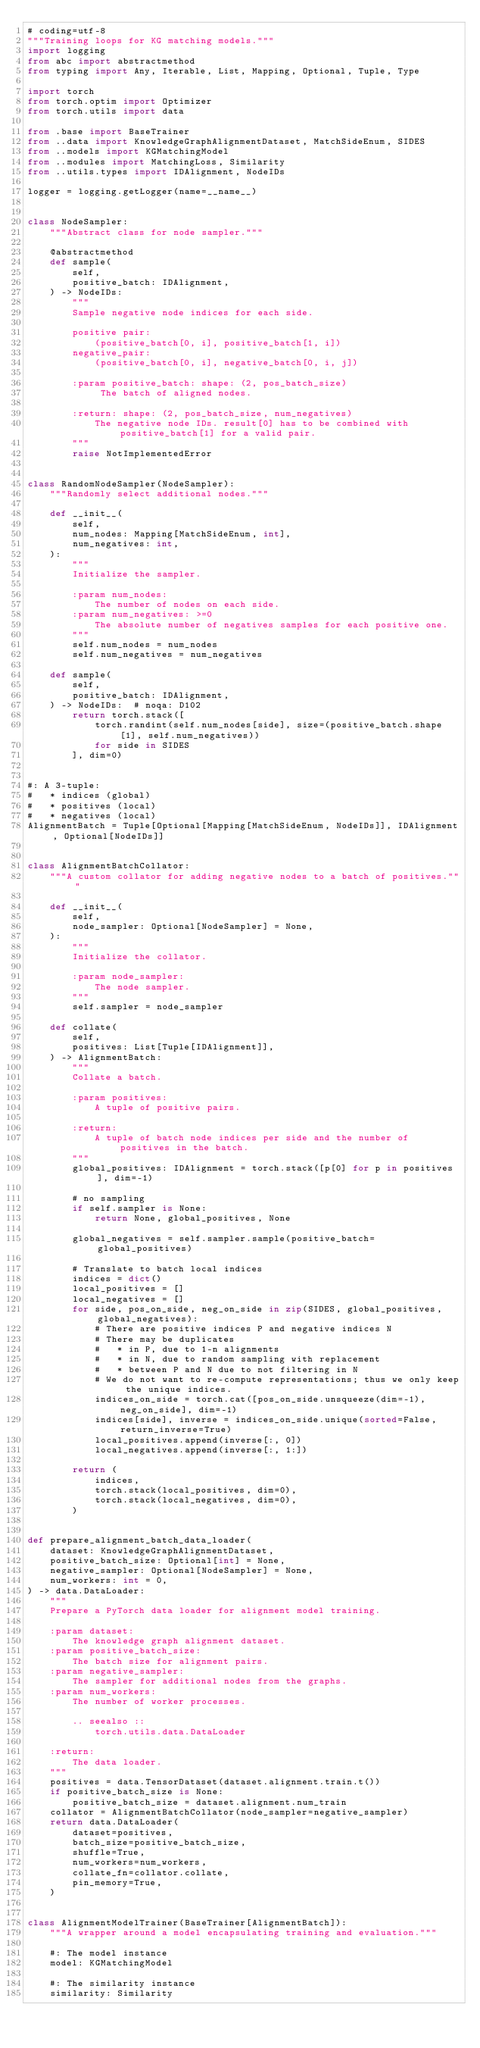Convert code to text. <code><loc_0><loc_0><loc_500><loc_500><_Python_># coding=utf-8
"""Training loops for KG matching models."""
import logging
from abc import abstractmethod
from typing import Any, Iterable, List, Mapping, Optional, Tuple, Type

import torch
from torch.optim import Optimizer
from torch.utils import data

from .base import BaseTrainer
from ..data import KnowledgeGraphAlignmentDataset, MatchSideEnum, SIDES
from ..models import KGMatchingModel
from ..modules import MatchingLoss, Similarity
from ..utils.types import IDAlignment, NodeIDs

logger = logging.getLogger(name=__name__)


class NodeSampler:
    """Abstract class for node sampler."""

    @abstractmethod
    def sample(
        self,
        positive_batch: IDAlignment,
    ) -> NodeIDs:
        """
        Sample negative node indices for each side.

        positive pair:
            (positive_batch[0, i], positive_batch[1, i])
        negative_pair:
            (positive_batch[0, i], negative_batch[0, i, j])

        :param positive_batch: shape: (2, pos_batch_size)
             The batch of aligned nodes.

        :return: shape: (2, pos_batch_size, num_negatives)
            The negative node IDs. result[0] has to be combined with positive_batch[1] for a valid pair.
        """
        raise NotImplementedError


class RandomNodeSampler(NodeSampler):
    """Randomly select additional nodes."""

    def __init__(
        self,
        num_nodes: Mapping[MatchSideEnum, int],
        num_negatives: int,
    ):
        """
        Initialize the sampler.

        :param num_nodes:
            The number of nodes on each side.
        :param num_negatives: >=0
            The absolute number of negatives samples for each positive one.
        """
        self.num_nodes = num_nodes
        self.num_negatives = num_negatives

    def sample(
        self,
        positive_batch: IDAlignment,
    ) -> NodeIDs:  # noqa: D102
        return torch.stack([
            torch.randint(self.num_nodes[side], size=(positive_batch.shape[1], self.num_negatives))
            for side in SIDES
        ], dim=0)


#: A 3-tuple:
#   * indices (global)
#   * positives (local)
#   * negatives (local)
AlignmentBatch = Tuple[Optional[Mapping[MatchSideEnum, NodeIDs]], IDAlignment, Optional[NodeIDs]]


class AlignmentBatchCollator:
    """A custom collator for adding negative nodes to a batch of positives."""

    def __init__(
        self,
        node_sampler: Optional[NodeSampler] = None,
    ):
        """
        Initialize the collator.

        :param node_sampler:
            The node sampler.
        """
        self.sampler = node_sampler

    def collate(
        self,
        positives: List[Tuple[IDAlignment]],
    ) -> AlignmentBatch:
        """
        Collate a batch.

        :param positives:
            A tuple of positive pairs.

        :return:
            A tuple of batch node indices per side and the number of positives in the batch.
        """
        global_positives: IDAlignment = torch.stack([p[0] for p in positives], dim=-1)

        # no sampling
        if self.sampler is None:
            return None, global_positives, None

        global_negatives = self.sampler.sample(positive_batch=global_positives)

        # Translate to batch local indices
        indices = dict()
        local_positives = []
        local_negatives = []
        for side, pos_on_side, neg_on_side in zip(SIDES, global_positives, global_negatives):
            # There are positive indices P and negative indices N
            # There may be duplicates
            #   * in P, due to 1-n alignments
            #   * in N, due to random sampling with replacement
            #   * between P and N due to not filtering in N
            # We do not want to re-compute representations; thus we only keep the unique indices.
            indices_on_side = torch.cat([pos_on_side.unsqueeze(dim=-1), neg_on_side], dim=-1)
            indices[side], inverse = indices_on_side.unique(sorted=False, return_inverse=True)
            local_positives.append(inverse[:, 0])
            local_negatives.append(inverse[:, 1:])

        return (
            indices,
            torch.stack(local_positives, dim=0),
            torch.stack(local_negatives, dim=0),
        )


def prepare_alignment_batch_data_loader(
    dataset: KnowledgeGraphAlignmentDataset,
    positive_batch_size: Optional[int] = None,
    negative_sampler: Optional[NodeSampler] = None,
    num_workers: int = 0,
) -> data.DataLoader:
    """
    Prepare a PyTorch data loader for alignment model training.

    :param dataset:
        The knowledge graph alignment dataset.
    :param positive_batch_size:
        The batch size for alignment pairs.
    :param negative_sampler:
        The sampler for additional nodes from the graphs.
    :param num_workers:
        The number of worker processes.

        .. seealso ::
            torch.utils.data.DataLoader

    :return:
        The data loader.
    """
    positives = data.TensorDataset(dataset.alignment.train.t())
    if positive_batch_size is None:
        positive_batch_size = dataset.alignment.num_train
    collator = AlignmentBatchCollator(node_sampler=negative_sampler)
    return data.DataLoader(
        dataset=positives,
        batch_size=positive_batch_size,
        shuffle=True,
        num_workers=num_workers,
        collate_fn=collator.collate,
        pin_memory=True,
    )


class AlignmentModelTrainer(BaseTrainer[AlignmentBatch]):
    """A wrapper around a model encapsulating training and evaluation."""

    #: The model instance
    model: KGMatchingModel

    #: The similarity instance
    similarity: Similarity
</code> 